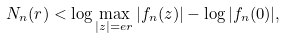Convert formula to latex. <formula><loc_0><loc_0><loc_500><loc_500>N _ { n } ( r ) < \log \max _ { | z | = e r } | f _ { n } ( z ) | - \log | f _ { n } ( 0 ) | ,</formula> 